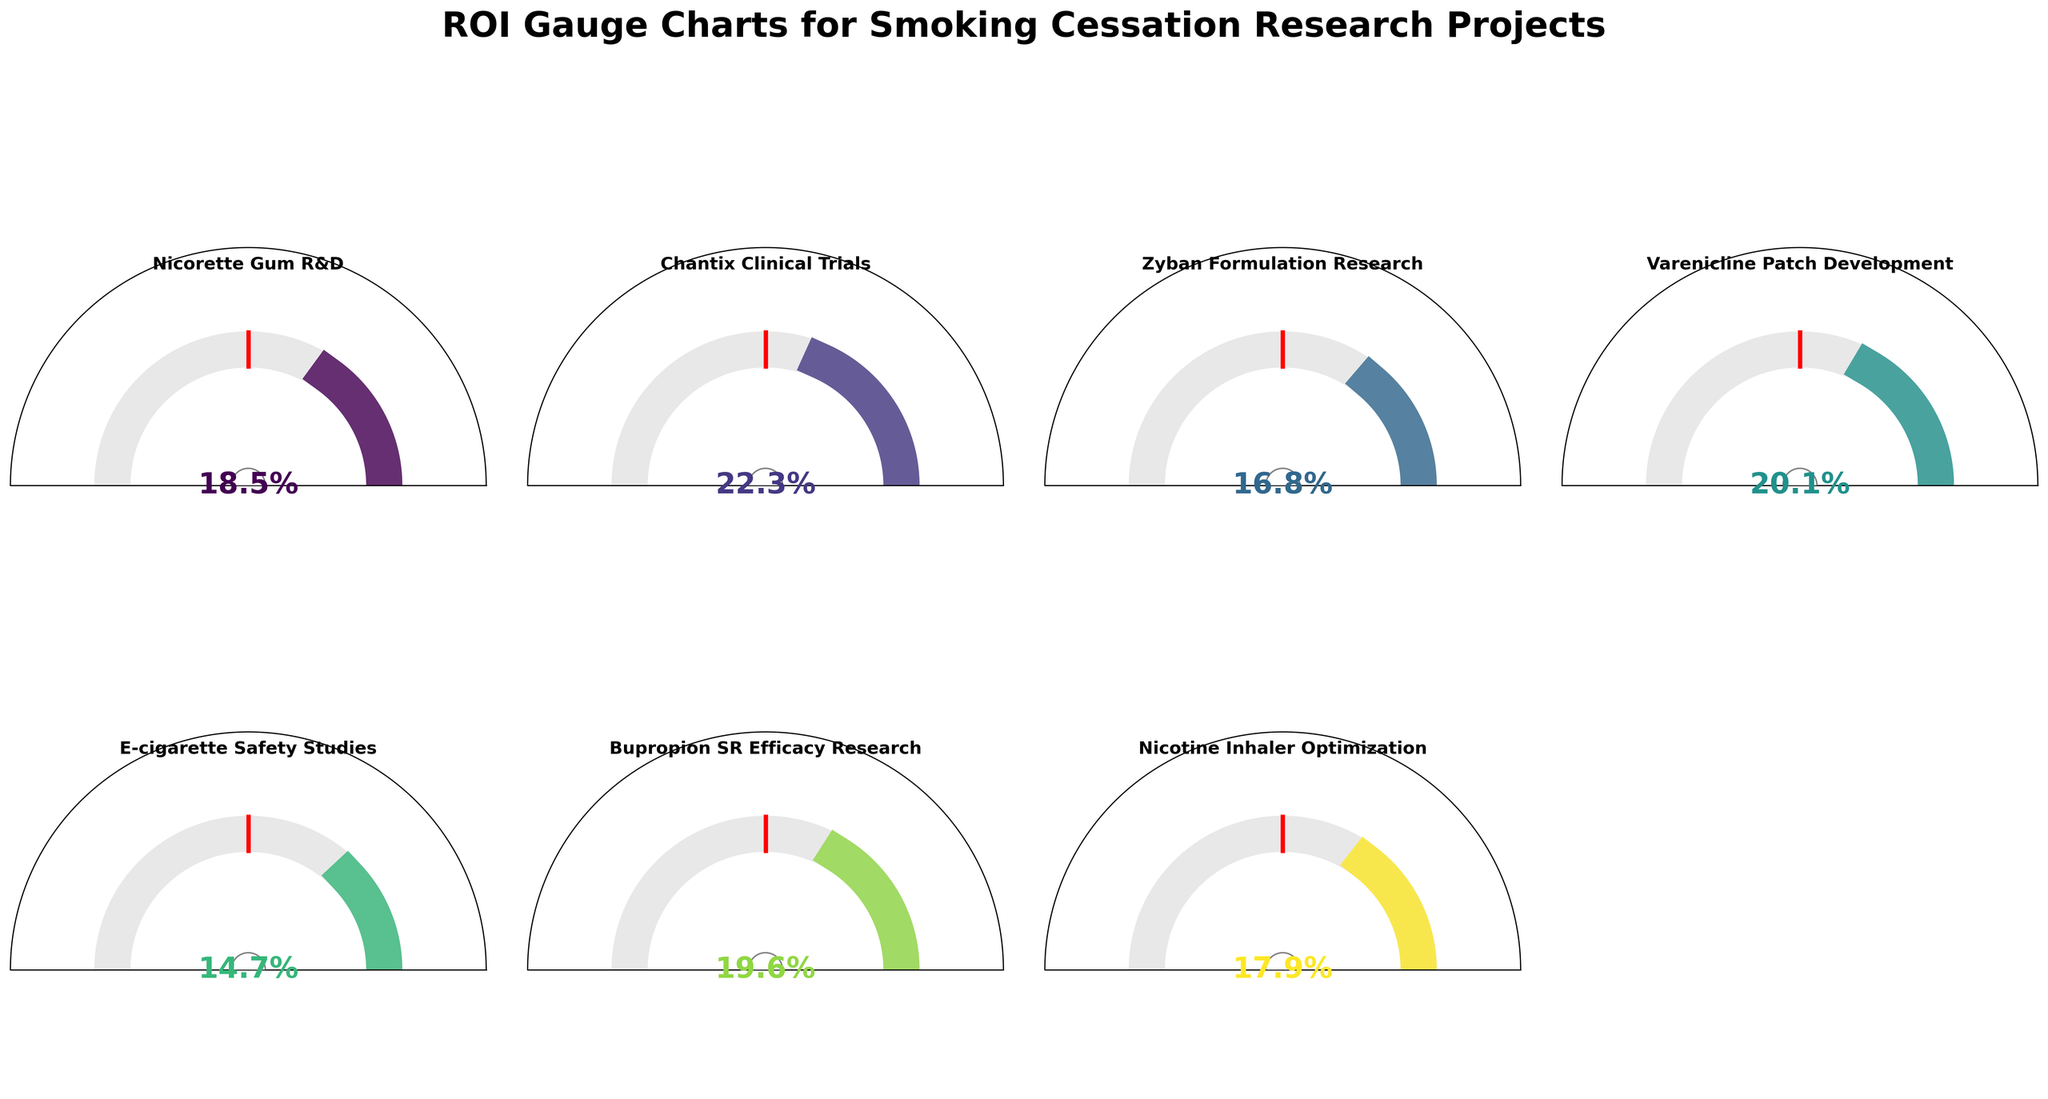How many research projects have a ROI higher than the industry average? By visually inspecting the gauge charts, count the number of projects where the ROI gauge extends further than the red industry average marker on each gauge.
Answer: 6 What research project has the highest ROI and what is the value? Identify the gauge chart with the longest arc and check the ROI value displayed in the center.
Answer: Chantix Clinical Trials, 22.3% Is there any research project with a ROI below the industry average? If so, name it. Look for a gauge chart where the ROI gauge does not reach the length of the red industry average marker and check the project name in the corresponding gauge.
Answer: E-cigarette Safety Studies What is the combined ROI of Nicorette Gum R&D and Chantix Clinical Trials? Add the ROI values of Nicorette Gum R&D (18.5%) and Chantix Clinical Trials (22.3%).
Answer: 40.8% Which research projects have an ROI between 17% and 20%? Find the gauge charts with ROI values in the center that fall within the 17%-20% range and note the project names.
Answer: Nicotine Inhaler Optimization, Nicorette Gum R&D, Bupropion SR Efficacy Research How much higher is the ROI of Varenicline Patch Development compared to Zyban Formulation Research? Subtract the ROI of Zyban Formulation Research (16.8%) from Varenicline Patch Development (20.1%).
Answer: 3.3% Which project has a ROI closest to the industry average? Identify the project whose ROI gauge is nearest to the red industry average marker.
Answer: E-cigarette Safety Studies Of the projects with a higher than industry average ROI, which one has the lowest ROI? Among the projects with gauge charts extending beyond the red marker, identify the chart with the smallest arc.
Answer: Nicorette Gum R&D How many research projects have a ROI above 20%? Count the gauge charts where the ROI value in the center exceeds 20%.
Answer: 2 What is the average ROI of all the research projects? Calculate the average by summing all ROI values (18.5 + 22.3 + 16.8 + 20.1 + 14.7 + 19.6 + 17.9) and dividing by the number of projects (7).
Answer: 18.27% 